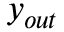Convert formula to latex. <formula><loc_0><loc_0><loc_500><loc_500>y _ { o u t }</formula> 